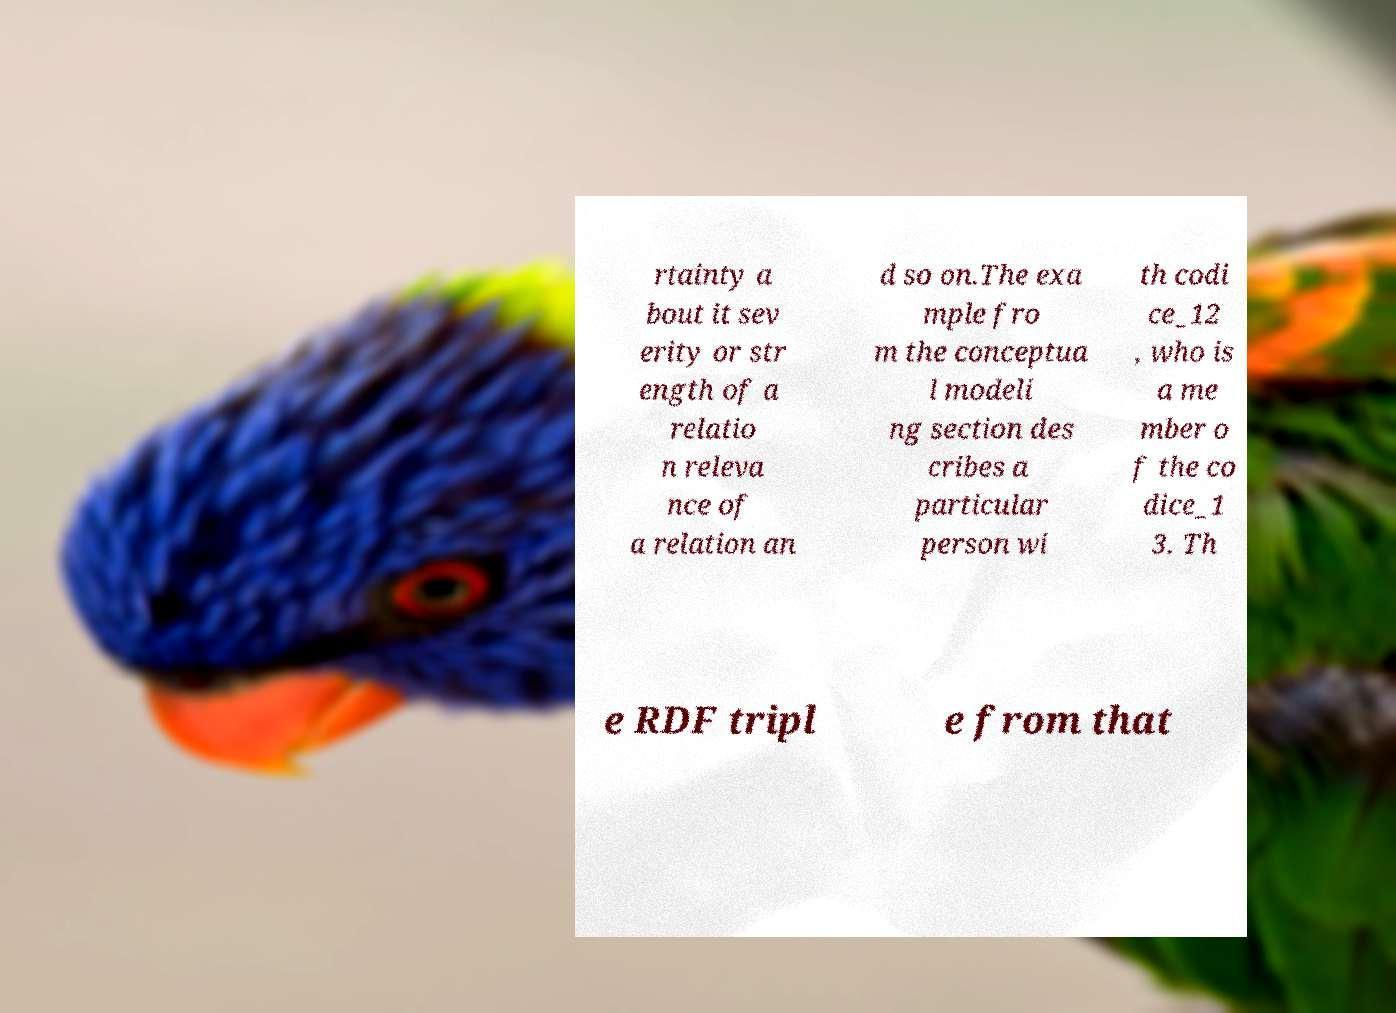Please identify and transcribe the text found in this image. rtainty a bout it sev erity or str ength of a relatio n releva nce of a relation an d so on.The exa mple fro m the conceptua l modeli ng section des cribes a particular person wi th codi ce_12 , who is a me mber o f the co dice_1 3. Th e RDF tripl e from that 